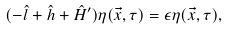Convert formula to latex. <formula><loc_0><loc_0><loc_500><loc_500>( - \hat { l } + \hat { h } + \hat { H } ^ { \prime } ) \eta ( \vec { x } , \tau ) = \epsilon \eta ( \vec { x } , \tau ) ,</formula> 